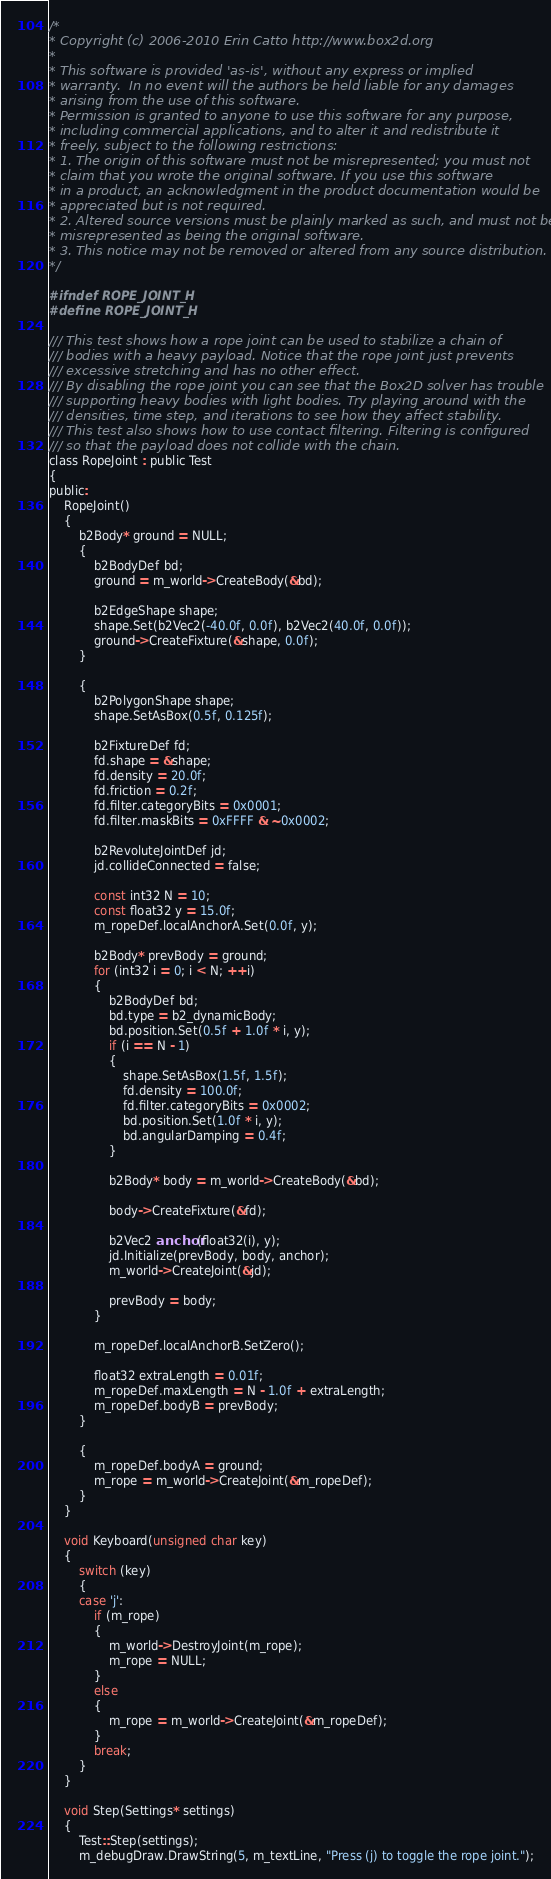Convert code to text. <code><loc_0><loc_0><loc_500><loc_500><_C_>/*
* Copyright (c) 2006-2010 Erin Catto http://www.box2d.org
*
* This software is provided 'as-is', without any express or implied
* warranty.  In no event will the authors be held liable for any damages
* arising from the use of this software.
* Permission is granted to anyone to use this software for any purpose,
* including commercial applications, and to alter it and redistribute it
* freely, subject to the following restrictions:
* 1. The origin of this software must not be misrepresented; you must not
* claim that you wrote the original software. If you use this software
* in a product, an acknowledgment in the product documentation would be
* appreciated but is not required.
* 2. Altered source versions must be plainly marked as such, and must not be
* misrepresented as being the original software.
* 3. This notice may not be removed or altered from any source distribution.
*/

#ifndef ROPE_JOINT_H
#define ROPE_JOINT_H

/// This test shows how a rope joint can be used to stabilize a chain of
/// bodies with a heavy payload. Notice that the rope joint just prevents
/// excessive stretching and has no other effect.
/// By disabling the rope joint you can see that the Box2D solver has trouble
/// supporting heavy bodies with light bodies. Try playing around with the
/// densities, time step, and iterations to see how they affect stability.
/// This test also shows how to use contact filtering. Filtering is configured
/// so that the payload does not collide with the chain.
class RopeJoint : public Test
{
public:
	RopeJoint()
	{
		b2Body* ground = NULL;
		{
			b2BodyDef bd;
			ground = m_world->CreateBody(&bd);

			b2EdgeShape shape;
			shape.Set(b2Vec2(-40.0f, 0.0f), b2Vec2(40.0f, 0.0f));
			ground->CreateFixture(&shape, 0.0f);
		}

		{
			b2PolygonShape shape;
			shape.SetAsBox(0.5f, 0.125f);

			b2FixtureDef fd;
			fd.shape = &shape;
			fd.density = 20.0f;
			fd.friction = 0.2f;
			fd.filter.categoryBits = 0x0001;
			fd.filter.maskBits = 0xFFFF & ~0x0002;

			b2RevoluteJointDef jd;
			jd.collideConnected = false;

			const int32 N = 10;
			const float32 y = 15.0f;
			m_ropeDef.localAnchorA.Set(0.0f, y);

			b2Body* prevBody = ground;
			for (int32 i = 0; i < N; ++i)
			{
				b2BodyDef bd;
				bd.type = b2_dynamicBody;
				bd.position.Set(0.5f + 1.0f * i, y);
				if (i == N - 1)
				{
					shape.SetAsBox(1.5f, 1.5f);
					fd.density = 100.0f;
					fd.filter.categoryBits = 0x0002;
					bd.position.Set(1.0f * i, y);
					bd.angularDamping = 0.4f;
				}

				b2Body* body = m_world->CreateBody(&bd);

				body->CreateFixture(&fd);

				b2Vec2 anchor(float32(i), y);
				jd.Initialize(prevBody, body, anchor);
				m_world->CreateJoint(&jd);

				prevBody = body;
			}

			m_ropeDef.localAnchorB.SetZero();

			float32 extraLength = 0.01f;
			m_ropeDef.maxLength = N - 1.0f + extraLength;
			m_ropeDef.bodyB = prevBody;
		}

		{
			m_ropeDef.bodyA = ground;
			m_rope = m_world->CreateJoint(&m_ropeDef);
		}
	}

	void Keyboard(unsigned char key)
	{
		switch (key)
		{
		case 'j':
			if (m_rope)
			{
				m_world->DestroyJoint(m_rope);
				m_rope = NULL;
			}
			else
			{
				m_rope = m_world->CreateJoint(&m_ropeDef);
			}
			break;
		}
	}

	void Step(Settings* settings)
	{
		Test::Step(settings);
		m_debugDraw.DrawString(5, m_textLine, "Press (j) to toggle the rope joint.");</code> 